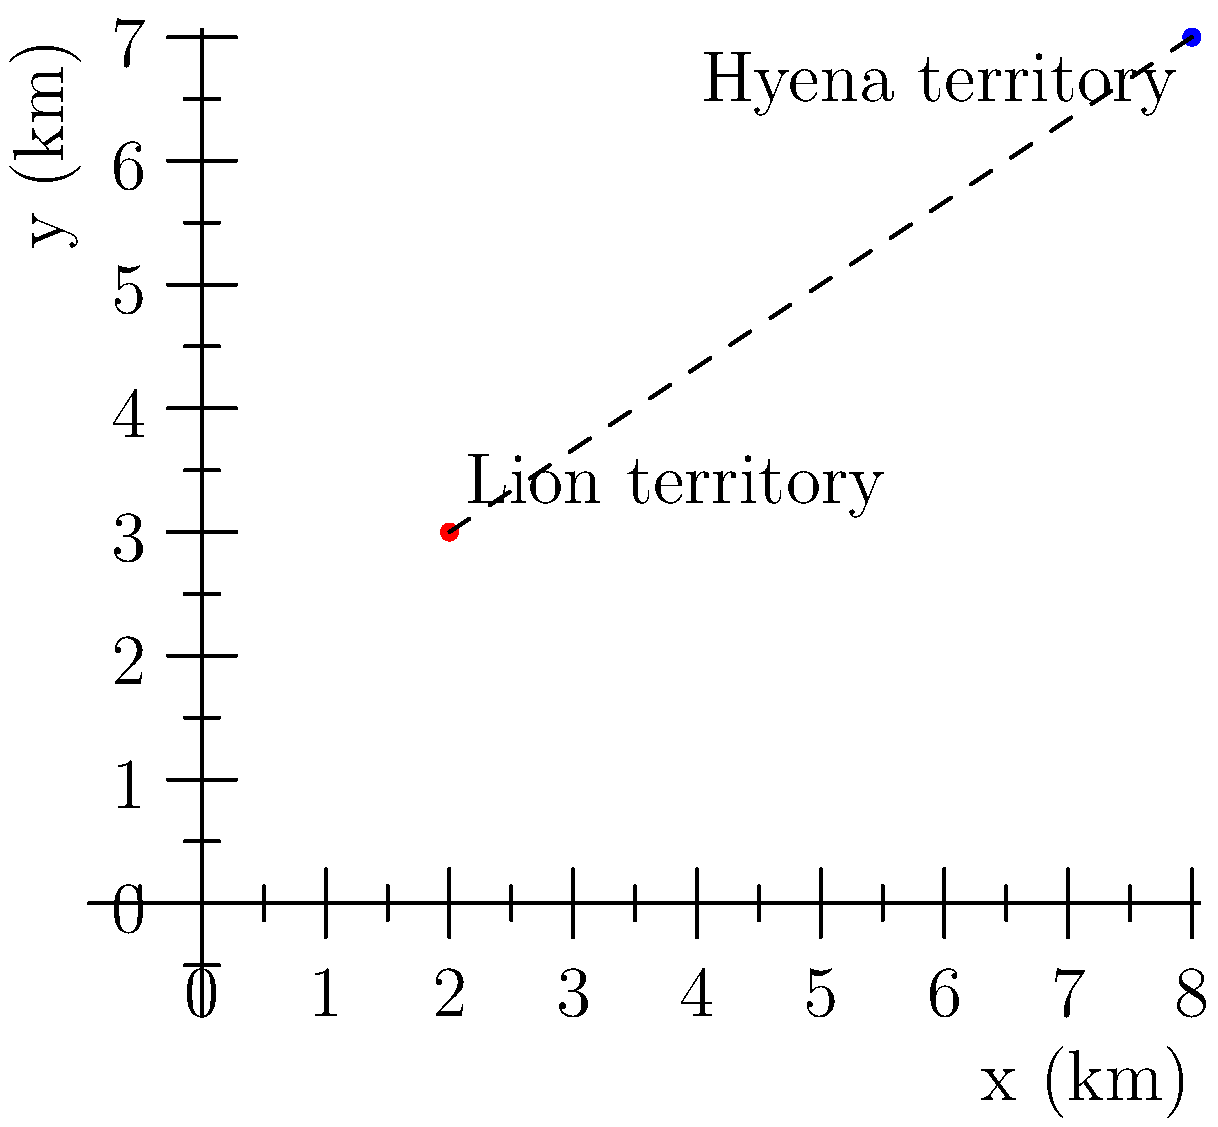As a zoologist studying predator-prey relationships, you're mapping the territories of lions and hyenas in a savanna ecosystem. The center of the lion territory is located at coordinates (2, 3) km, while the center of the hyena territory is at (8, 7) km. Using the distance formula, calculate the distance between these two territorial centers to determine the potential for interspecies conflict. To solve this problem, we'll use the distance formula derived from the Pythagorean theorem:

$$d = \sqrt{(x_2 - x_1)^2 + (y_2 - y_1)^2}$$

Where:
$(x_1, y_1)$ is the coordinate of the lion territory (2, 3)
$(x_2, y_2)$ is the coordinate of the hyena territory (8, 7)

Let's plug these values into the formula:

$$d = \sqrt{(8 - 2)^2 + (7 - 3)^2}$$

Simplify the expressions inside the parentheses:

$$d = \sqrt{6^2 + 4^2}$$

Calculate the squares:

$$d = \sqrt{36 + 16}$$

Add the values under the square root:

$$d = \sqrt{52}$$

Simplify the square root:

$$d = 2\sqrt{13}$$

Therefore, the distance between the centers of the lion and hyena territories is $2\sqrt{13}$ km.
Answer: $2\sqrt{13}$ km 